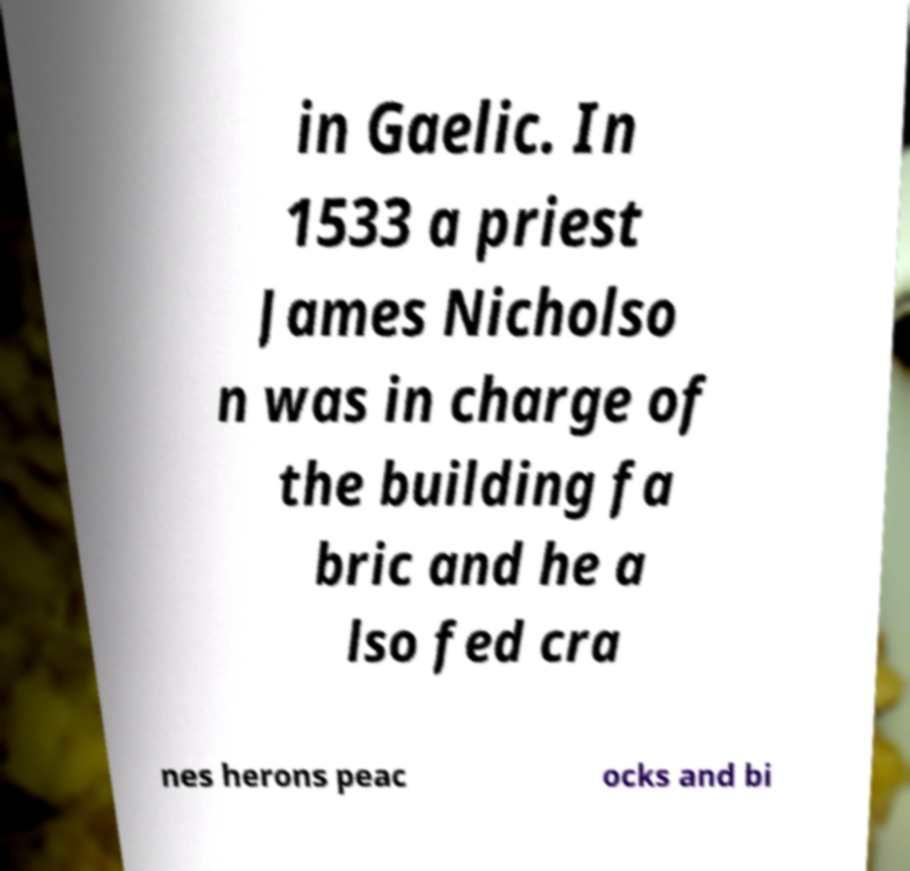I need the written content from this picture converted into text. Can you do that? in Gaelic. In 1533 a priest James Nicholso n was in charge of the building fa bric and he a lso fed cra nes herons peac ocks and bi 